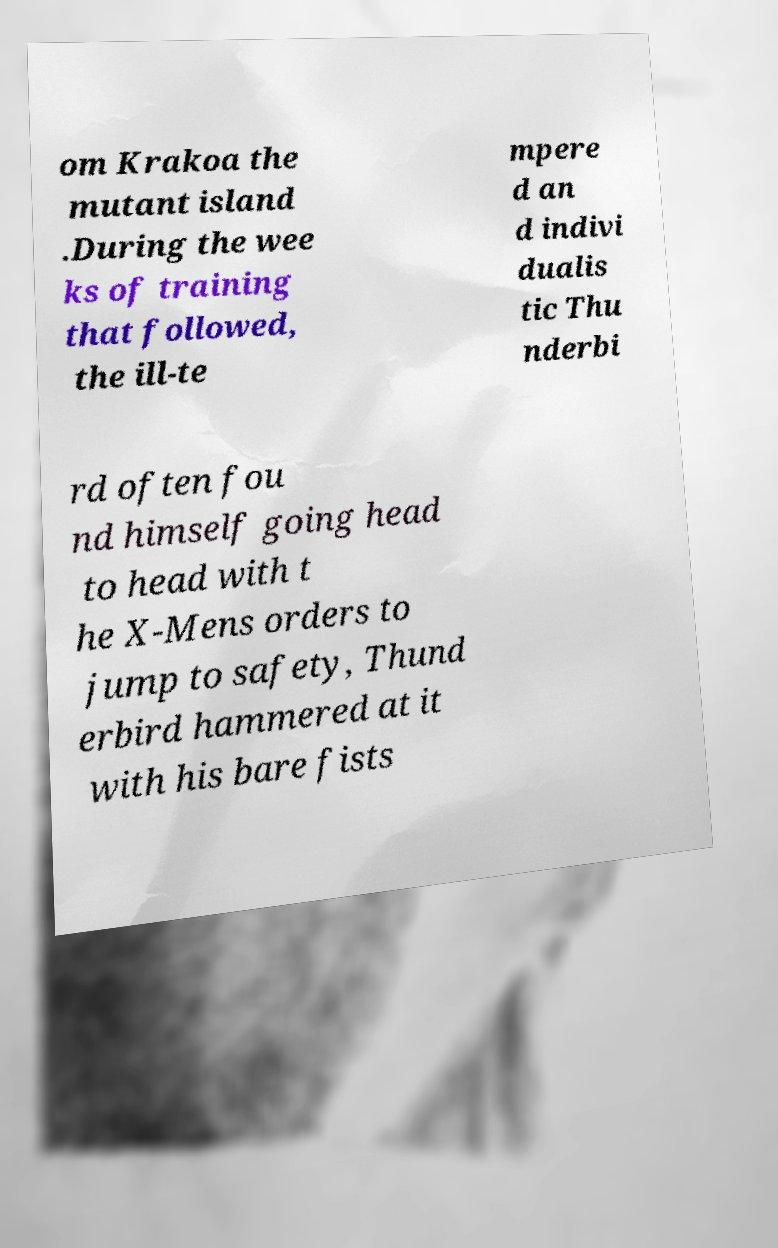Can you read and provide the text displayed in the image?This photo seems to have some interesting text. Can you extract and type it out for me? om Krakoa the mutant island .During the wee ks of training that followed, the ill-te mpere d an d indivi dualis tic Thu nderbi rd often fou nd himself going head to head with t he X-Mens orders to jump to safety, Thund erbird hammered at it with his bare fists 